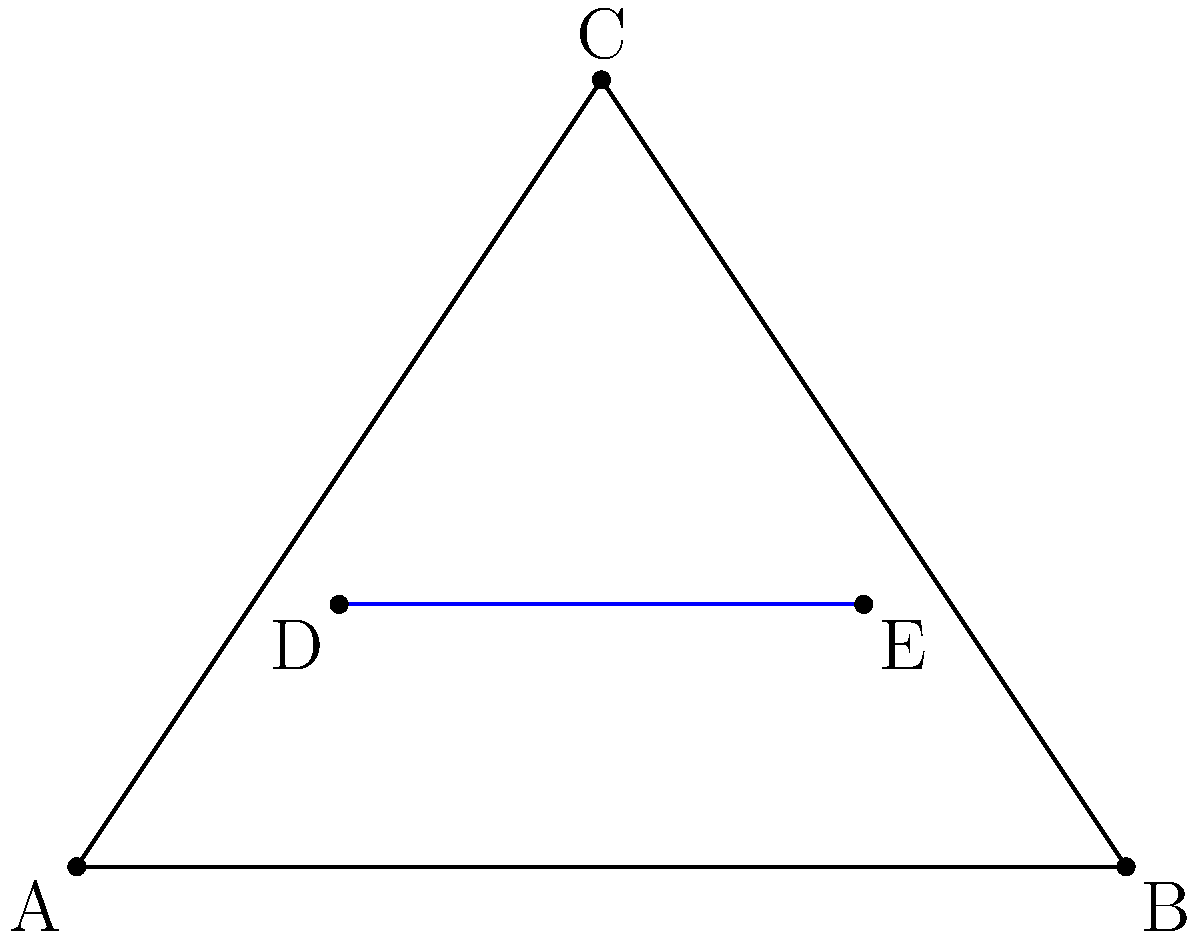In the diagram representing a surgical incision plan on a patient's abdomen, line DE is parallel to side AB of triangle ABC. If AD = 1 cm, DB = 3 cm, and DE = 2 cm, what is the length of AE in centimeters? To solve this problem, we'll use the concept of similar triangles and the properties of parallel lines. Let's follow these steps:

1) Since DE is parallel to AB, triangles ADE and ABC are similar.

2) In similar triangles, the ratio of corresponding sides is constant. We can use this property to set up a proportion:

   $$\frac{AD}{DB} = \frac{AE}{EB}$$

3) We know that AD = 1 cm and DB = 3 cm. Let's substitute these values:

   $$\frac{1}{3} = \frac{AE}{EB}$$

4) We also know that DE = 2 cm, and DE = AE + EB. Let's express EB in terms of AE:

   EB = 2 - AE

5) Substituting this into our proportion:

   $$\frac{1}{3} = \frac{AE}{2 - AE}$$

6) Cross multiply:

   $$1(2 - AE) = 3AE$$
   $$2 - AE = 3AE$$
   $$2 = 4AE$$

7) Solve for AE:

   $$AE = \frac{2}{4} = 0.5$$

Therefore, the length of AE is 0.5 cm.
Answer: 0.5 cm 